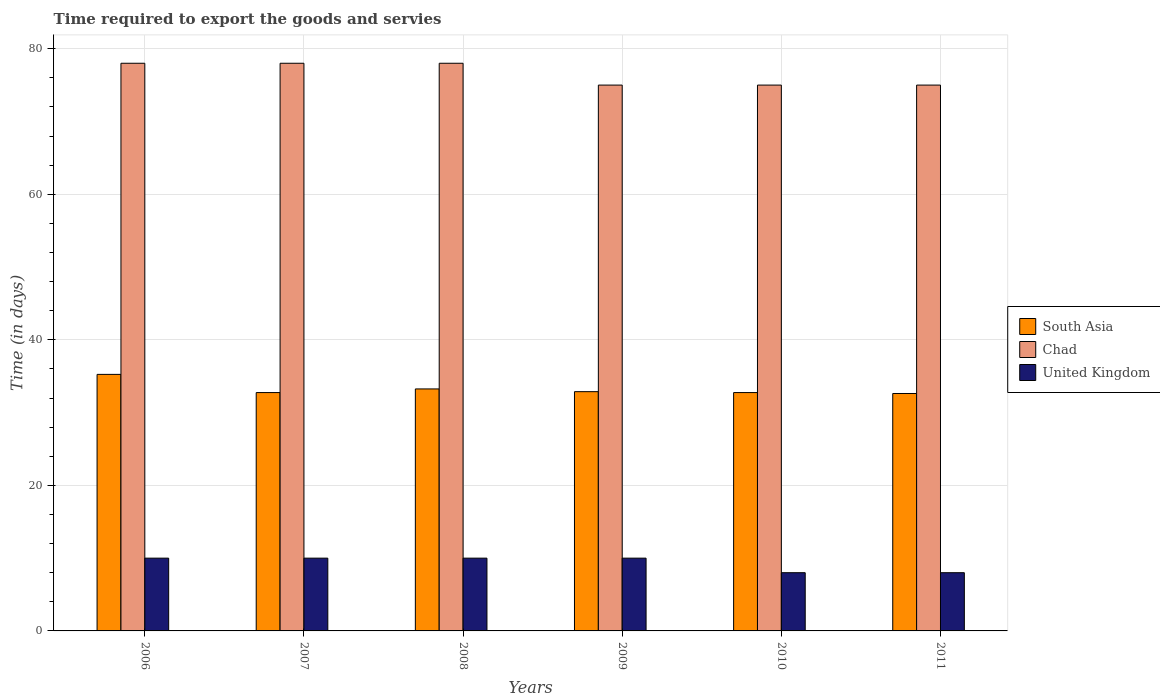How many different coloured bars are there?
Keep it short and to the point. 3. Are the number of bars on each tick of the X-axis equal?
Offer a very short reply. Yes. What is the label of the 6th group of bars from the left?
Ensure brevity in your answer.  2011. In how many cases, is the number of bars for a given year not equal to the number of legend labels?
Give a very brief answer. 0. What is the number of days required to export the goods and services in South Asia in 2007?
Make the answer very short. 32.75. Across all years, what is the maximum number of days required to export the goods and services in United Kingdom?
Give a very brief answer. 10. Across all years, what is the minimum number of days required to export the goods and services in South Asia?
Provide a succinct answer. 32.62. In which year was the number of days required to export the goods and services in Chad maximum?
Offer a very short reply. 2006. What is the total number of days required to export the goods and services in Chad in the graph?
Ensure brevity in your answer.  459. What is the difference between the number of days required to export the goods and services in Chad in 2008 and that in 2009?
Keep it short and to the point. 3. What is the difference between the number of days required to export the goods and services in Chad in 2008 and the number of days required to export the goods and services in United Kingdom in 2009?
Offer a very short reply. 68. What is the average number of days required to export the goods and services in Chad per year?
Keep it short and to the point. 76.5. In the year 2007, what is the difference between the number of days required to export the goods and services in United Kingdom and number of days required to export the goods and services in South Asia?
Provide a succinct answer. -22.75. In how many years, is the number of days required to export the goods and services in South Asia greater than 28 days?
Give a very brief answer. 6. What is the ratio of the number of days required to export the goods and services in Chad in 2006 to that in 2008?
Give a very brief answer. 1. Is the number of days required to export the goods and services in Chad in 2009 less than that in 2010?
Provide a short and direct response. No. What is the difference between the highest and the lowest number of days required to export the goods and services in United Kingdom?
Your answer should be very brief. 2. What does the 1st bar from the left in 2009 represents?
Your answer should be very brief. South Asia. What does the 2nd bar from the right in 2008 represents?
Give a very brief answer. Chad. How many years are there in the graph?
Ensure brevity in your answer.  6. How many legend labels are there?
Your answer should be very brief. 3. How are the legend labels stacked?
Provide a succinct answer. Vertical. What is the title of the graph?
Your answer should be very brief. Time required to export the goods and servies. What is the label or title of the X-axis?
Offer a terse response. Years. What is the label or title of the Y-axis?
Offer a very short reply. Time (in days). What is the Time (in days) of South Asia in 2006?
Offer a very short reply. 35.25. What is the Time (in days) in South Asia in 2007?
Give a very brief answer. 32.75. What is the Time (in days) in Chad in 2007?
Offer a very short reply. 78. What is the Time (in days) in United Kingdom in 2007?
Make the answer very short. 10. What is the Time (in days) in South Asia in 2008?
Your answer should be very brief. 33.25. What is the Time (in days) of Chad in 2008?
Provide a succinct answer. 78. What is the Time (in days) of United Kingdom in 2008?
Give a very brief answer. 10. What is the Time (in days) of South Asia in 2009?
Ensure brevity in your answer.  32.88. What is the Time (in days) in South Asia in 2010?
Give a very brief answer. 32.75. What is the Time (in days) of Chad in 2010?
Keep it short and to the point. 75. What is the Time (in days) in South Asia in 2011?
Provide a short and direct response. 32.62. What is the Time (in days) in United Kingdom in 2011?
Your answer should be very brief. 8. Across all years, what is the maximum Time (in days) in South Asia?
Provide a short and direct response. 35.25. Across all years, what is the maximum Time (in days) in Chad?
Ensure brevity in your answer.  78. Across all years, what is the minimum Time (in days) of South Asia?
Keep it short and to the point. 32.62. Across all years, what is the minimum Time (in days) of Chad?
Your answer should be compact. 75. Across all years, what is the minimum Time (in days) in United Kingdom?
Keep it short and to the point. 8. What is the total Time (in days) of South Asia in the graph?
Make the answer very short. 199.5. What is the total Time (in days) in Chad in the graph?
Give a very brief answer. 459. What is the total Time (in days) of United Kingdom in the graph?
Ensure brevity in your answer.  56. What is the difference between the Time (in days) of South Asia in 2006 and that in 2007?
Keep it short and to the point. 2.5. What is the difference between the Time (in days) of South Asia in 2006 and that in 2008?
Your answer should be very brief. 2. What is the difference between the Time (in days) in South Asia in 2006 and that in 2009?
Your answer should be very brief. 2.38. What is the difference between the Time (in days) of Chad in 2006 and that in 2010?
Keep it short and to the point. 3. What is the difference between the Time (in days) in United Kingdom in 2006 and that in 2010?
Provide a succinct answer. 2. What is the difference between the Time (in days) in South Asia in 2006 and that in 2011?
Your answer should be very brief. 2.62. What is the difference between the Time (in days) in Chad in 2007 and that in 2008?
Make the answer very short. 0. What is the difference between the Time (in days) in United Kingdom in 2007 and that in 2008?
Your answer should be very brief. 0. What is the difference between the Time (in days) of South Asia in 2007 and that in 2009?
Ensure brevity in your answer.  -0.12. What is the difference between the Time (in days) of Chad in 2007 and that in 2009?
Ensure brevity in your answer.  3. What is the difference between the Time (in days) in Chad in 2007 and that in 2010?
Provide a short and direct response. 3. What is the difference between the Time (in days) in United Kingdom in 2007 and that in 2010?
Your answer should be compact. 2. What is the difference between the Time (in days) of South Asia in 2007 and that in 2011?
Make the answer very short. 0.12. What is the difference between the Time (in days) of United Kingdom in 2007 and that in 2011?
Your answer should be compact. 2. What is the difference between the Time (in days) in South Asia in 2008 and that in 2009?
Your response must be concise. 0.38. What is the difference between the Time (in days) in United Kingdom in 2008 and that in 2009?
Make the answer very short. 0. What is the difference between the Time (in days) in South Asia in 2008 and that in 2010?
Provide a short and direct response. 0.5. What is the difference between the Time (in days) of South Asia in 2008 and that in 2011?
Give a very brief answer. 0.62. What is the difference between the Time (in days) in Chad in 2008 and that in 2011?
Give a very brief answer. 3. What is the difference between the Time (in days) of United Kingdom in 2008 and that in 2011?
Your response must be concise. 2. What is the difference between the Time (in days) in South Asia in 2009 and that in 2010?
Provide a succinct answer. 0.12. What is the difference between the Time (in days) of United Kingdom in 2009 and that in 2010?
Provide a succinct answer. 2. What is the difference between the Time (in days) of South Asia in 2009 and that in 2011?
Your answer should be very brief. 0.25. What is the difference between the Time (in days) of United Kingdom in 2009 and that in 2011?
Offer a terse response. 2. What is the difference between the Time (in days) in Chad in 2010 and that in 2011?
Offer a very short reply. 0. What is the difference between the Time (in days) of South Asia in 2006 and the Time (in days) of Chad in 2007?
Offer a terse response. -42.75. What is the difference between the Time (in days) of South Asia in 2006 and the Time (in days) of United Kingdom in 2007?
Your answer should be compact. 25.25. What is the difference between the Time (in days) of Chad in 2006 and the Time (in days) of United Kingdom in 2007?
Offer a terse response. 68. What is the difference between the Time (in days) in South Asia in 2006 and the Time (in days) in Chad in 2008?
Make the answer very short. -42.75. What is the difference between the Time (in days) in South Asia in 2006 and the Time (in days) in United Kingdom in 2008?
Provide a short and direct response. 25.25. What is the difference between the Time (in days) of South Asia in 2006 and the Time (in days) of Chad in 2009?
Your answer should be compact. -39.75. What is the difference between the Time (in days) of South Asia in 2006 and the Time (in days) of United Kingdom in 2009?
Give a very brief answer. 25.25. What is the difference between the Time (in days) in Chad in 2006 and the Time (in days) in United Kingdom in 2009?
Your answer should be compact. 68. What is the difference between the Time (in days) of South Asia in 2006 and the Time (in days) of Chad in 2010?
Your response must be concise. -39.75. What is the difference between the Time (in days) in South Asia in 2006 and the Time (in days) in United Kingdom in 2010?
Offer a very short reply. 27.25. What is the difference between the Time (in days) in South Asia in 2006 and the Time (in days) in Chad in 2011?
Offer a very short reply. -39.75. What is the difference between the Time (in days) in South Asia in 2006 and the Time (in days) in United Kingdom in 2011?
Make the answer very short. 27.25. What is the difference between the Time (in days) in South Asia in 2007 and the Time (in days) in Chad in 2008?
Offer a very short reply. -45.25. What is the difference between the Time (in days) of South Asia in 2007 and the Time (in days) of United Kingdom in 2008?
Your response must be concise. 22.75. What is the difference between the Time (in days) of South Asia in 2007 and the Time (in days) of Chad in 2009?
Keep it short and to the point. -42.25. What is the difference between the Time (in days) of South Asia in 2007 and the Time (in days) of United Kingdom in 2009?
Offer a terse response. 22.75. What is the difference between the Time (in days) of South Asia in 2007 and the Time (in days) of Chad in 2010?
Your response must be concise. -42.25. What is the difference between the Time (in days) in South Asia in 2007 and the Time (in days) in United Kingdom in 2010?
Ensure brevity in your answer.  24.75. What is the difference between the Time (in days) in Chad in 2007 and the Time (in days) in United Kingdom in 2010?
Offer a terse response. 70. What is the difference between the Time (in days) in South Asia in 2007 and the Time (in days) in Chad in 2011?
Make the answer very short. -42.25. What is the difference between the Time (in days) in South Asia in 2007 and the Time (in days) in United Kingdom in 2011?
Provide a short and direct response. 24.75. What is the difference between the Time (in days) of South Asia in 2008 and the Time (in days) of Chad in 2009?
Provide a succinct answer. -41.75. What is the difference between the Time (in days) of South Asia in 2008 and the Time (in days) of United Kingdom in 2009?
Ensure brevity in your answer.  23.25. What is the difference between the Time (in days) of Chad in 2008 and the Time (in days) of United Kingdom in 2009?
Your answer should be compact. 68. What is the difference between the Time (in days) of South Asia in 2008 and the Time (in days) of Chad in 2010?
Your answer should be compact. -41.75. What is the difference between the Time (in days) of South Asia in 2008 and the Time (in days) of United Kingdom in 2010?
Offer a very short reply. 25.25. What is the difference between the Time (in days) of South Asia in 2008 and the Time (in days) of Chad in 2011?
Give a very brief answer. -41.75. What is the difference between the Time (in days) of South Asia in 2008 and the Time (in days) of United Kingdom in 2011?
Provide a short and direct response. 25.25. What is the difference between the Time (in days) of South Asia in 2009 and the Time (in days) of Chad in 2010?
Provide a succinct answer. -42.12. What is the difference between the Time (in days) of South Asia in 2009 and the Time (in days) of United Kingdom in 2010?
Your response must be concise. 24.88. What is the difference between the Time (in days) of South Asia in 2009 and the Time (in days) of Chad in 2011?
Provide a short and direct response. -42.12. What is the difference between the Time (in days) of South Asia in 2009 and the Time (in days) of United Kingdom in 2011?
Ensure brevity in your answer.  24.88. What is the difference between the Time (in days) of Chad in 2009 and the Time (in days) of United Kingdom in 2011?
Provide a short and direct response. 67. What is the difference between the Time (in days) in South Asia in 2010 and the Time (in days) in Chad in 2011?
Your response must be concise. -42.25. What is the difference between the Time (in days) of South Asia in 2010 and the Time (in days) of United Kingdom in 2011?
Your response must be concise. 24.75. What is the average Time (in days) in South Asia per year?
Make the answer very short. 33.25. What is the average Time (in days) of Chad per year?
Offer a very short reply. 76.5. What is the average Time (in days) in United Kingdom per year?
Offer a terse response. 9.33. In the year 2006, what is the difference between the Time (in days) of South Asia and Time (in days) of Chad?
Offer a very short reply. -42.75. In the year 2006, what is the difference between the Time (in days) in South Asia and Time (in days) in United Kingdom?
Keep it short and to the point. 25.25. In the year 2006, what is the difference between the Time (in days) in Chad and Time (in days) in United Kingdom?
Your answer should be very brief. 68. In the year 2007, what is the difference between the Time (in days) of South Asia and Time (in days) of Chad?
Offer a very short reply. -45.25. In the year 2007, what is the difference between the Time (in days) in South Asia and Time (in days) in United Kingdom?
Provide a succinct answer. 22.75. In the year 2007, what is the difference between the Time (in days) of Chad and Time (in days) of United Kingdom?
Provide a succinct answer. 68. In the year 2008, what is the difference between the Time (in days) of South Asia and Time (in days) of Chad?
Keep it short and to the point. -44.75. In the year 2008, what is the difference between the Time (in days) of South Asia and Time (in days) of United Kingdom?
Ensure brevity in your answer.  23.25. In the year 2009, what is the difference between the Time (in days) in South Asia and Time (in days) in Chad?
Provide a succinct answer. -42.12. In the year 2009, what is the difference between the Time (in days) of South Asia and Time (in days) of United Kingdom?
Give a very brief answer. 22.88. In the year 2009, what is the difference between the Time (in days) in Chad and Time (in days) in United Kingdom?
Your answer should be very brief. 65. In the year 2010, what is the difference between the Time (in days) in South Asia and Time (in days) in Chad?
Your response must be concise. -42.25. In the year 2010, what is the difference between the Time (in days) in South Asia and Time (in days) in United Kingdom?
Your response must be concise. 24.75. In the year 2011, what is the difference between the Time (in days) of South Asia and Time (in days) of Chad?
Provide a short and direct response. -42.38. In the year 2011, what is the difference between the Time (in days) in South Asia and Time (in days) in United Kingdom?
Offer a terse response. 24.62. What is the ratio of the Time (in days) in South Asia in 2006 to that in 2007?
Give a very brief answer. 1.08. What is the ratio of the Time (in days) of United Kingdom in 2006 to that in 2007?
Your response must be concise. 1. What is the ratio of the Time (in days) in South Asia in 2006 to that in 2008?
Offer a terse response. 1.06. What is the ratio of the Time (in days) of Chad in 2006 to that in 2008?
Provide a short and direct response. 1. What is the ratio of the Time (in days) of United Kingdom in 2006 to that in 2008?
Your answer should be compact. 1. What is the ratio of the Time (in days) of South Asia in 2006 to that in 2009?
Your response must be concise. 1.07. What is the ratio of the Time (in days) in United Kingdom in 2006 to that in 2009?
Make the answer very short. 1. What is the ratio of the Time (in days) in South Asia in 2006 to that in 2010?
Offer a very short reply. 1.08. What is the ratio of the Time (in days) of United Kingdom in 2006 to that in 2010?
Offer a terse response. 1.25. What is the ratio of the Time (in days) in South Asia in 2006 to that in 2011?
Provide a short and direct response. 1.08. What is the ratio of the Time (in days) in United Kingdom in 2006 to that in 2011?
Offer a very short reply. 1.25. What is the ratio of the Time (in days) in Chad in 2007 to that in 2009?
Your answer should be compact. 1.04. What is the ratio of the Time (in days) in South Asia in 2007 to that in 2010?
Your answer should be very brief. 1. What is the ratio of the Time (in days) in Chad in 2007 to that in 2010?
Provide a succinct answer. 1.04. What is the ratio of the Time (in days) of United Kingdom in 2007 to that in 2011?
Ensure brevity in your answer.  1.25. What is the ratio of the Time (in days) of South Asia in 2008 to that in 2009?
Provide a short and direct response. 1.01. What is the ratio of the Time (in days) of Chad in 2008 to that in 2009?
Your answer should be compact. 1.04. What is the ratio of the Time (in days) of United Kingdom in 2008 to that in 2009?
Your answer should be compact. 1. What is the ratio of the Time (in days) in South Asia in 2008 to that in 2010?
Offer a very short reply. 1.02. What is the ratio of the Time (in days) of Chad in 2008 to that in 2010?
Your answer should be compact. 1.04. What is the ratio of the Time (in days) in South Asia in 2008 to that in 2011?
Provide a short and direct response. 1.02. What is the ratio of the Time (in days) of South Asia in 2009 to that in 2010?
Your answer should be compact. 1. What is the ratio of the Time (in days) of Chad in 2009 to that in 2010?
Ensure brevity in your answer.  1. What is the ratio of the Time (in days) of United Kingdom in 2009 to that in 2010?
Give a very brief answer. 1.25. What is the ratio of the Time (in days) of South Asia in 2009 to that in 2011?
Offer a very short reply. 1.01. What is the ratio of the Time (in days) of Chad in 2009 to that in 2011?
Give a very brief answer. 1. What is the ratio of the Time (in days) of United Kingdom in 2009 to that in 2011?
Provide a succinct answer. 1.25. What is the ratio of the Time (in days) in United Kingdom in 2010 to that in 2011?
Offer a very short reply. 1. What is the difference between the highest and the second highest Time (in days) in United Kingdom?
Provide a succinct answer. 0. What is the difference between the highest and the lowest Time (in days) of South Asia?
Provide a succinct answer. 2.62. What is the difference between the highest and the lowest Time (in days) in United Kingdom?
Make the answer very short. 2. 